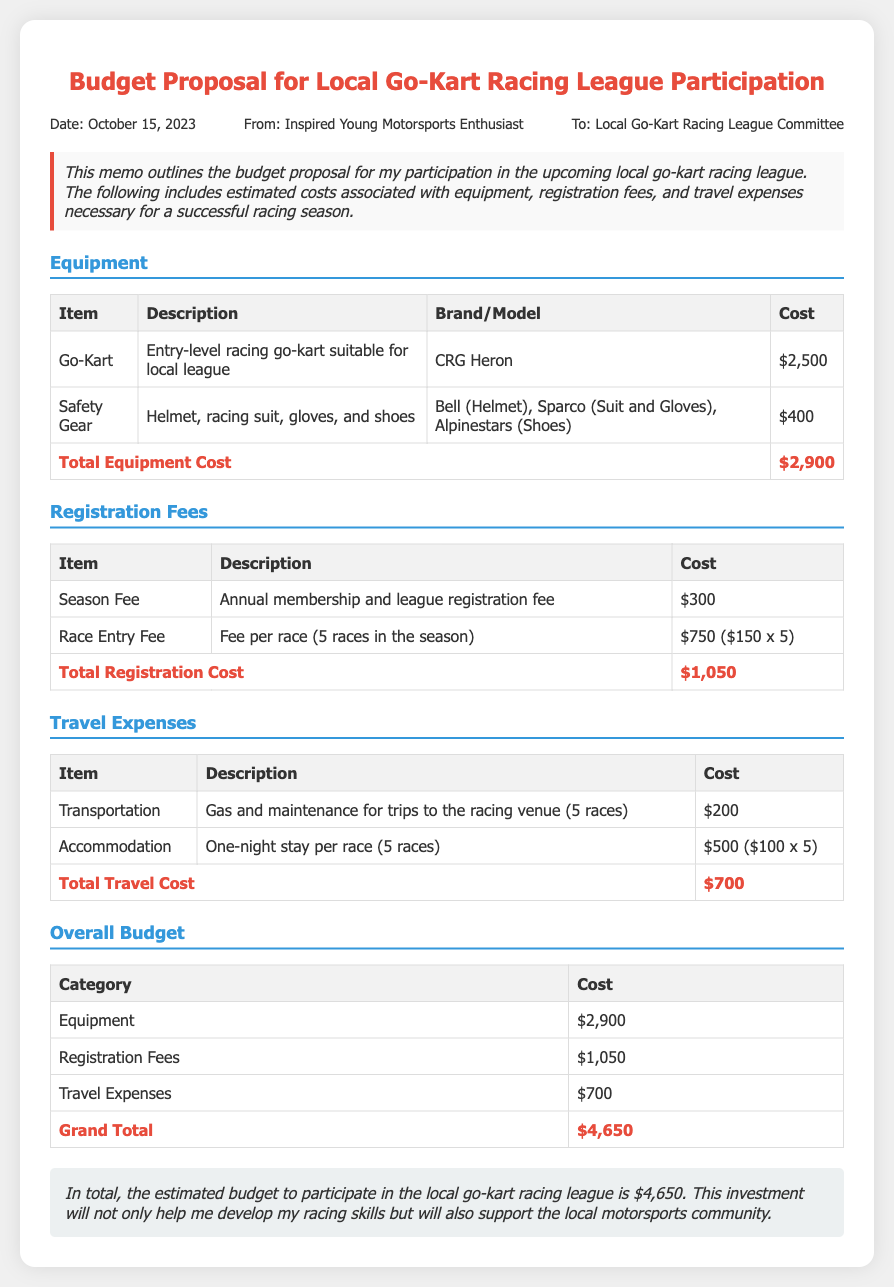what is the date of the memo? The date mentioned in the memo is specified in the header section under "Date."
Answer: October 15, 2023 who is the author of the memo? The author of the memo is indicated in the header section under "From."
Answer: Inspired Young Motorsports Enthusiast how much does the go-kart cost? The cost of the go-kart is provided in the equipment section of the document.
Answer: $2,500 what is the total cost for registration fees? The total cost for registration fees is given in the registration fees section, summing up the season fee and race entry fee.
Answer: $1,050 how many races are included in the season? The number of races for the season is mentioned in the description of the race entry fee.
Answer: 5 races what is the total travel cost? The total travel cost is calculated by adding the transportation and accommodation costs, stated in the travel expenses section.
Answer: $700 what is the grand total budget proposal amount? The grand total is indicated in the overall budget section by summing up all expenses.
Answer: $4,650 what items are included in the safety gear? The safety gear is described in the equipment section, listing the components needed.
Answer: Helmet, racing suit, gloves, and shoes what is the cost of accommodation per race? The cost for accommodation is provided in the travel expenses section, broken down to per race cost.
Answer: $100 